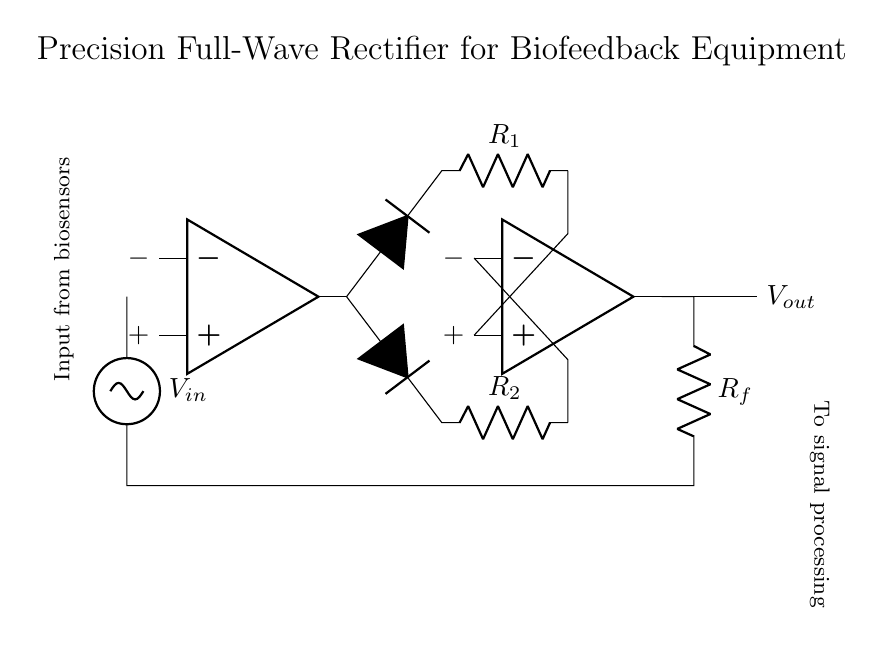What is the input voltage of the circuit? The input voltage is denoted as V_in, which is connected from the voltage source to the circuit.
Answer: V_in How many operational amplifiers are used in this circuit? The circuit contains two operational amplifiers, which are indicated by the two op amp symbols.
Answer: 2 What is the function of the diodes in this circuit? The diodes are used to allow current to flow in only one direction, effectively rectifying the input signal to ensure that both halves of the AC waveform are utilized in the output.
Answer: Rectification What are the resistor values in the circuit? The circuit includes resistors R_1, R_2, and R_f, which are indicated with their labels next to them in the schematic, representing different parts of the circuit.
Answer: R_1, R_2, R_f What type of rectifier is depicted in the diagram? The diagram illustrates a precision full-wave rectifier, which is designed to accurately convert both the positive and negative halves of an input AC signal into a corresponding DC output.
Answer: Precision full-wave rectifier How does the feedback loop affect the output? The feedback loop connects the output of the second operational amplifier back into the circuit, enabling stable gain and accurate tracking of the input signal, thus enhancing the precision of the rectification.
Answer: Stabilizes output What is the output of this circuit intended for? The output of the circuit is directed to signal processing, which is indicated by the label written next to the output node in the diagram, signaling that processed biofeedback data is the final goal.
Answer: Signal processing 